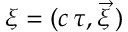Convert formula to latex. <formula><loc_0><loc_0><loc_500><loc_500>\xi = ( c \, \tau , \vec { \xi } \, )</formula> 